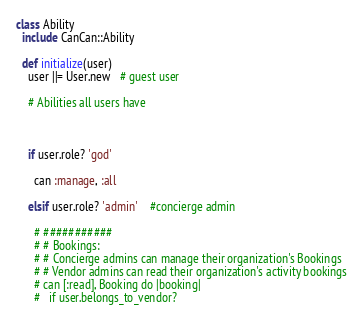Convert code to text. <code><loc_0><loc_0><loc_500><loc_500><_Ruby_>class Ability
  include CanCan::Ability
  
  def initialize(user)
    user ||= User.new   # guest user

    # Abilities all users have


    
    if user.role? 'god'

      can :manage, :all

    elsif user.role? 'admin'    #concierge admin

      # ###########
      # # Bookings: 
      # # Concierge admins can manage their organization's Bookings
      # # Vendor admins can read their organization's activity bookings
      # can [:read], Booking do |booking|
      #   if user.belongs_to_vendor?</code> 